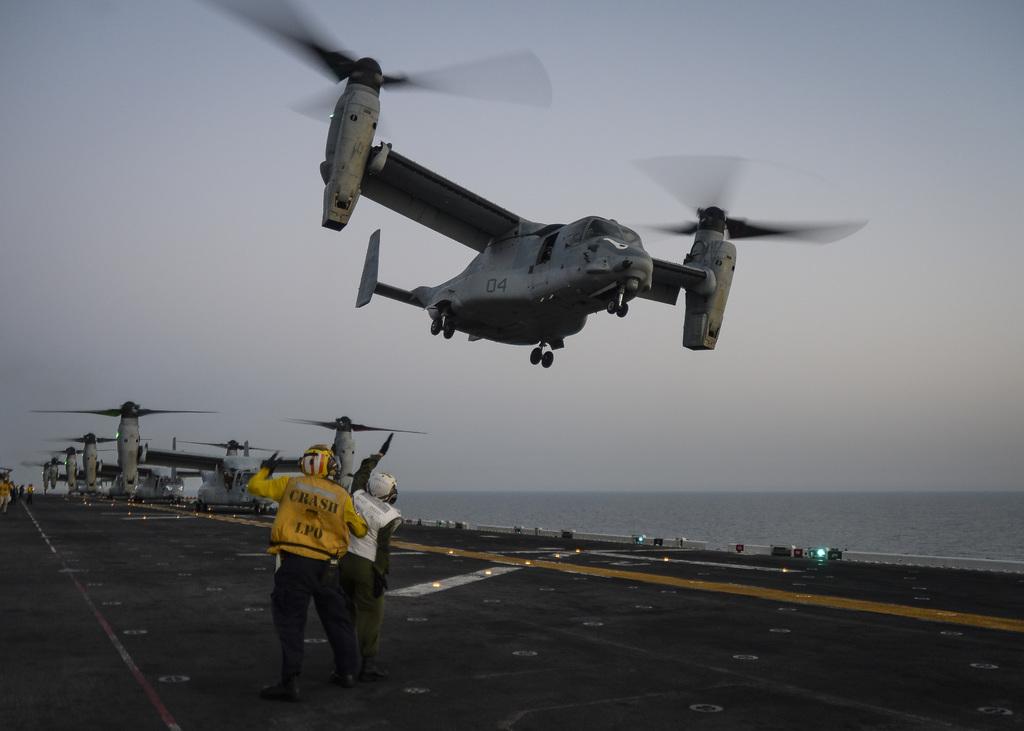What number is on the helicopter?
Your answer should be very brief. 04. 